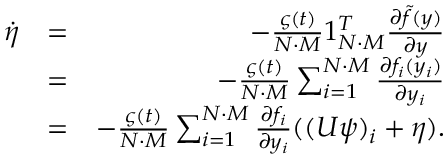Convert formula to latex. <formula><loc_0><loc_0><loc_500><loc_500>\begin{array} { r l r } { \dot { \eta } } & { = } & { - \frac { \varsigma ( t ) } { N \cdot M } 1 _ { N \cdot M } ^ { T } \frac { \partial \tilde { f } ( y ) } { \partial y } } \\ & { = } & { - \frac { \varsigma ( t ) } { N \cdot M } \sum _ { i = 1 } ^ { N \cdot M } \frac { \partial f _ { i } ( y _ { i } ) } { \partial y _ { i } } } \\ & { = } & { - \frac { \varsigma ( t ) } { N \cdot M } \sum _ { i = 1 } ^ { N \cdot M } \frac { \partial f _ { i } } { \partial y _ { i } } ( ( U \psi ) _ { i } + \eta ) . } \end{array}</formula> 